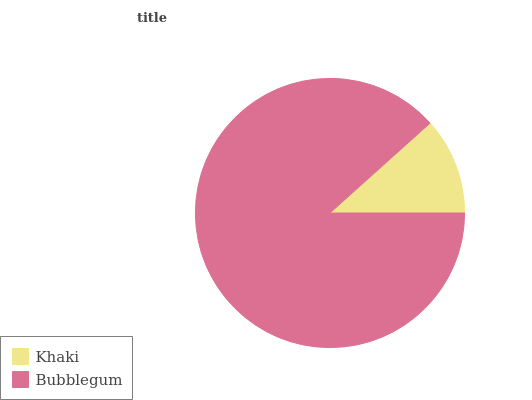Is Khaki the minimum?
Answer yes or no. Yes. Is Bubblegum the maximum?
Answer yes or no. Yes. Is Bubblegum the minimum?
Answer yes or no. No. Is Bubblegum greater than Khaki?
Answer yes or no. Yes. Is Khaki less than Bubblegum?
Answer yes or no. Yes. Is Khaki greater than Bubblegum?
Answer yes or no. No. Is Bubblegum less than Khaki?
Answer yes or no. No. Is Bubblegum the high median?
Answer yes or no. Yes. Is Khaki the low median?
Answer yes or no. Yes. Is Khaki the high median?
Answer yes or no. No. Is Bubblegum the low median?
Answer yes or no. No. 